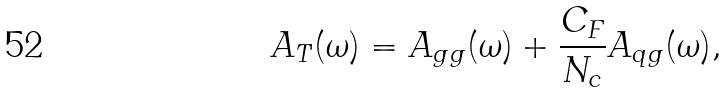<formula> <loc_0><loc_0><loc_500><loc_500>A _ { T } ( \omega ) = A _ { g g } ( \omega ) + \frac { C _ { F } } { N _ { c } } A _ { q g } ( \omega ) ,</formula> 